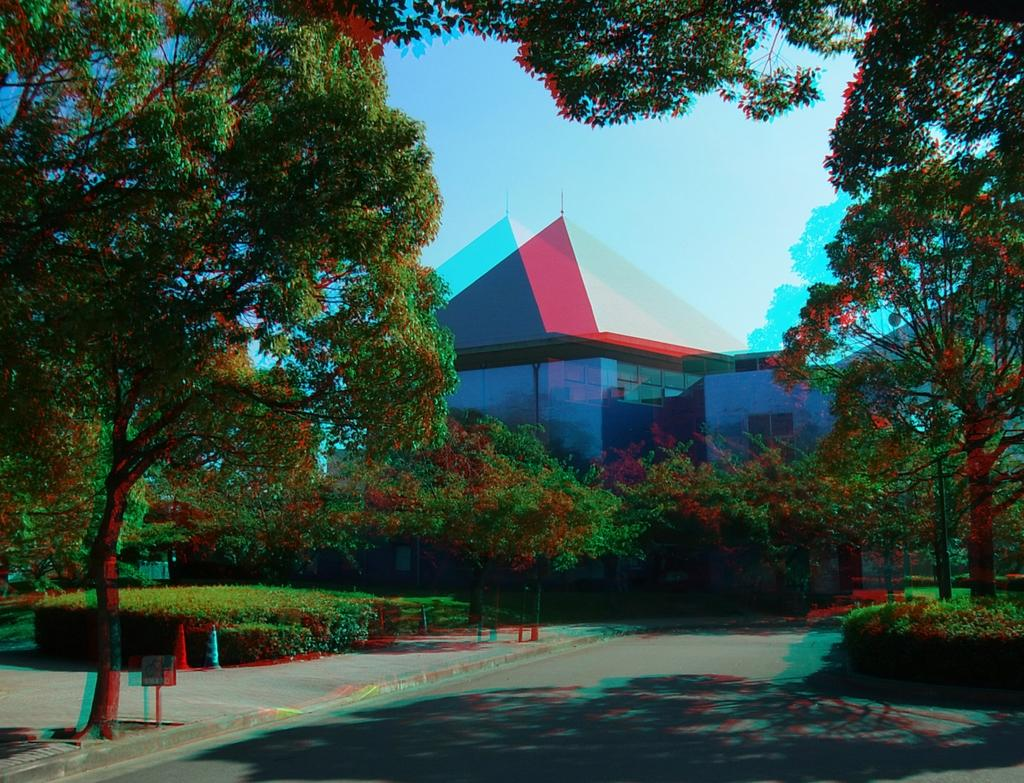What type of structure can be seen in the image? There is a building in the image. What other elements are present in the image besides the building? There are trees and traffic cones visible in the image. What can be seen in the background of the image? The sky is visible in the image. What type of wrist accessory is visible on the building in the image? There is no wrist accessory present on the building in the image. How many eggs are visible in the image? There are no eggs present in the image. 